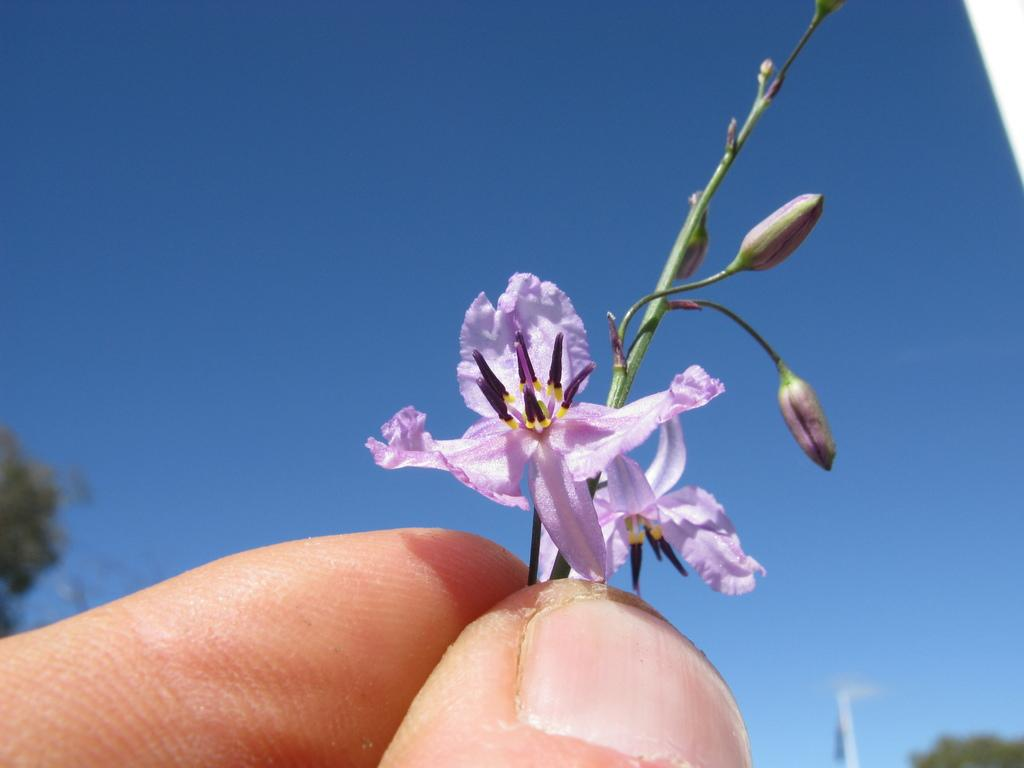What is the person in the image holding? The person is holding flowers in the image. Can you describe the flowers being held? The person is holding a stem with flower buds. What can be seen in the background of the image? There is the sky and trees visible in the background of the image. What type of canvas is the person using to paint the action in the image? There is no canvas or painting activity present in the image. 